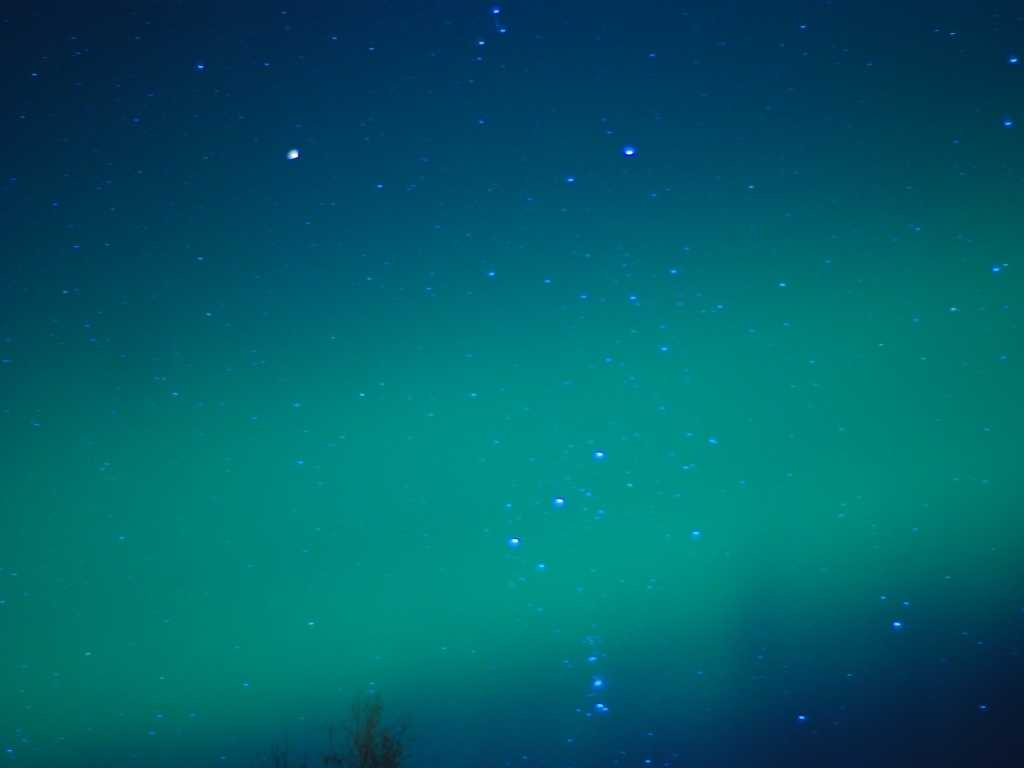Does the image have vibrant colors? The image showcases an array of captivating colors in the night sky. With a gradient from a deep shade of teal that seems to dance with the twinkling stars, to an almost ethereal green hue, one can feel the vibrancy of the cosmic scene. So, to answer the question: Yes, the image does have vibrant colors, creating a soothing yet lively spectacle that draws the observer into the vastness of the universe. 